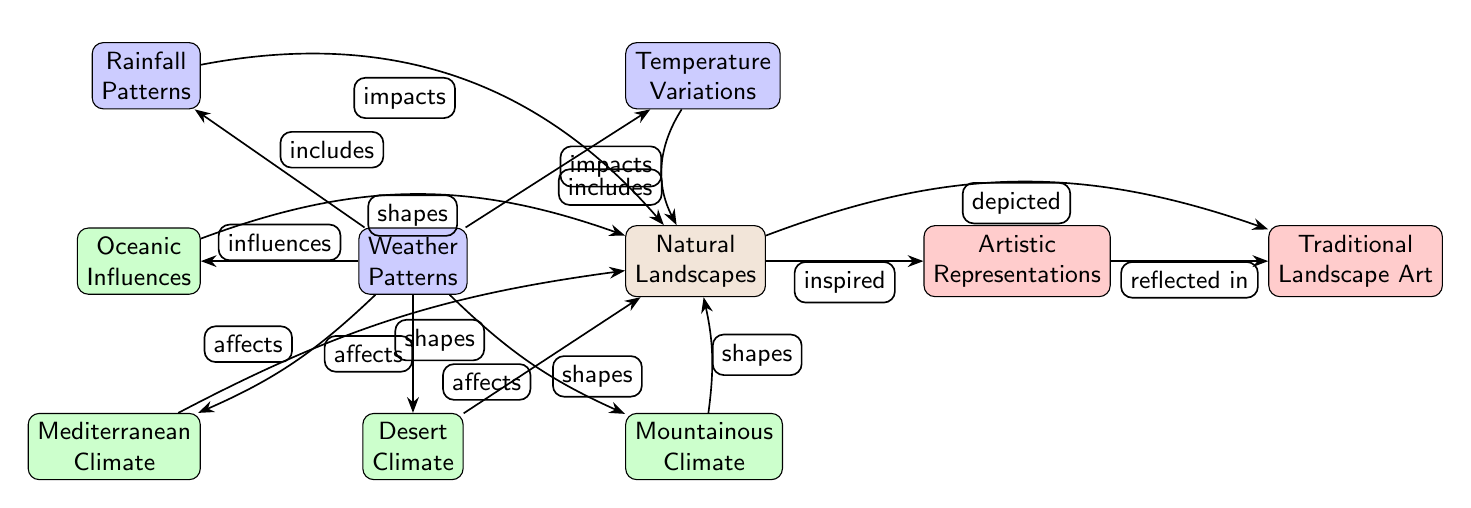What are the two types of weather patterns included in the diagram? The diagram indicates two specific weather patterns, namely "Rainfall Patterns" and "Temperature Variations," which are mentioned under "Weather Patterns."
Answer: Rainfall Patterns, Temperature Variations How many climates are mentioned in the diagram? The diagram lists four distinct climates: Mediterranean Climate, Desert Climate, Mountainous Climate, and Oceanic Influences, which can be counted to provide the answer.
Answer: 4 What does "Weather Patterns" influence according to the diagram? The diagram shows that "Weather Patterns" influences "Oceanic Influences," implying that it shapes the overall natural landscape depicted within the artistic representations.
Answer: Oceanic Influences What does "Natural Landscapes" inspire? From the diagram, it is evident that "Natural Landscapes" inspires "Artistic Representations," linking nature with artistic expression.
Answer: Artistic Representations Which climate has a direct effect on shaping the "Natural Landscapes"? Examining the connections, "Mediterranean Climate," "Desert Climate," and "Mountainous Climate" all have arrows directing to "Natural Landscapes," indicating their impact.
Answer: Mediterranean Climate, Desert Climate, Mountainous Climate What were the two weather factors mentioned that impact "Natural Landscapes"? The diagram explicitly shows that "Rainfall Patterns" and "Temperature Variations" impact "Natural Landscapes," indicating their roles in shaping the environment.
Answer: Rainfall Patterns, Temperature Variations How is "Artistic Representations" reflected in the diagram? "Artistic Representations" is reflected by the connection from "Natural Landscapes," indicating that the beauty and form of landscapes serve as a basis for artistic interpretation in artwork.
Answer: Natural Landscapes What is the relationship between "Natural Landscapes" and "Traditional Landscape Art"? The diagram illustrates a direct relationship where "Natural Landscapes" are depicted in "Traditional Landscape Art," suggesting a representation of nature in this specific art form.
Answer: Depicted 